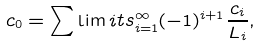Convert formula to latex. <formula><loc_0><loc_0><loc_500><loc_500>c _ { 0 } = \sum \lim i t s _ { i = 1 } ^ { \infty } ( - 1 ) ^ { i + 1 } \frac { c _ { i } } { L _ { i } } ,</formula> 